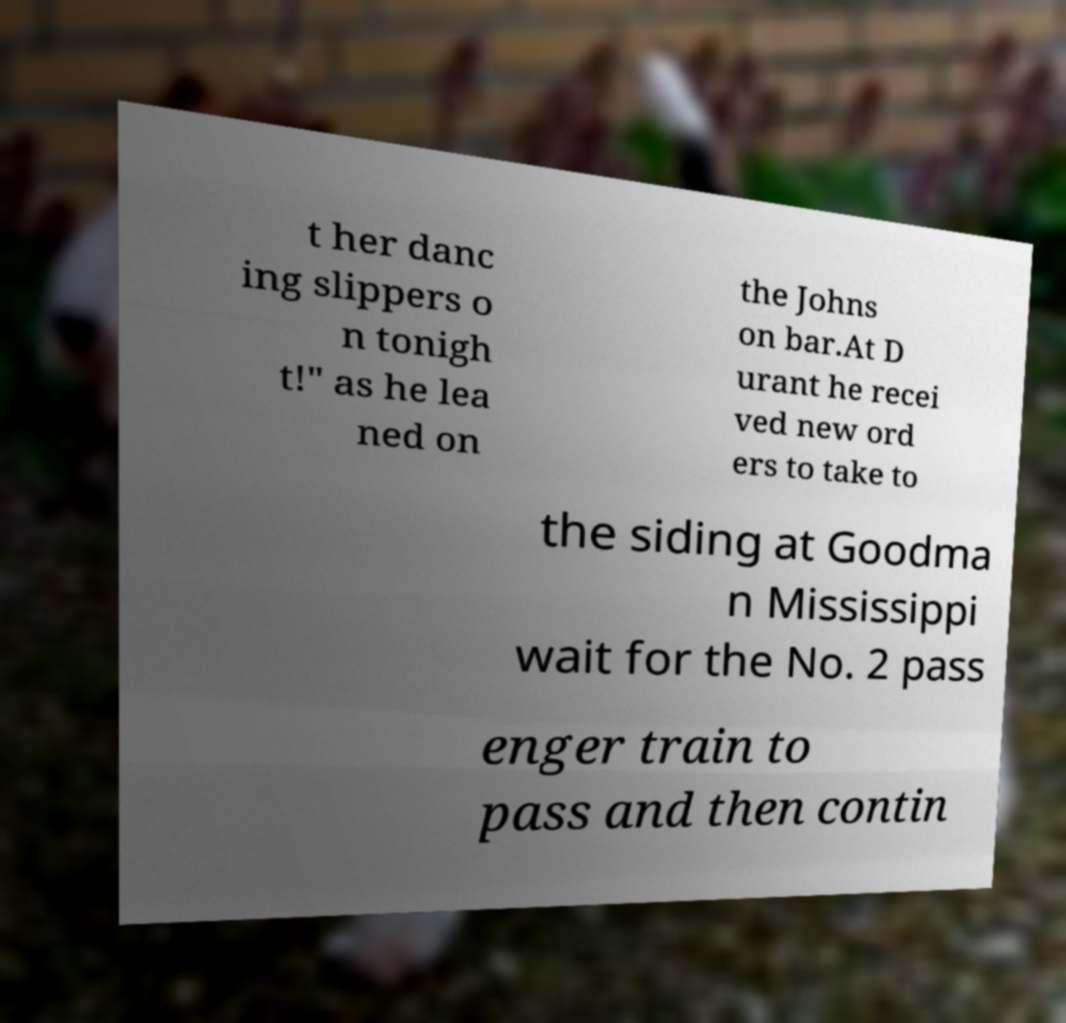Can you accurately transcribe the text from the provided image for me? t her danc ing slippers o n tonigh t!" as he lea ned on the Johns on bar.At D urant he recei ved new ord ers to take to the siding at Goodma n Mississippi wait for the No. 2 pass enger train to pass and then contin 